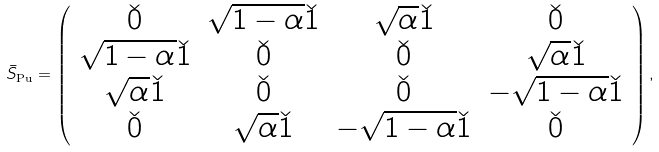Convert formula to latex. <formula><loc_0><loc_0><loc_500><loc_500>\bar { S } _ { \text {Pu} } = \left ( \begin{array} { c c c c } \check { 0 } & \sqrt { 1 - \alpha } \check { 1 } & \sqrt { \alpha } \check { 1 } & \check { 0 } \\ \sqrt { 1 - \alpha } \check { 1 } & \check { 0 } & \check { 0 } & \sqrt { \alpha } \check { 1 } \\ \sqrt { \alpha } \check { 1 } & \check { 0 } & \check { 0 } & - \sqrt { 1 - \alpha } \check { 1 } \\ \check { 0 } & \sqrt { \alpha } \check { 1 } & - \sqrt { 1 - \alpha } \check { 1 } & \check { 0 } \end{array} \right ) ,</formula> 